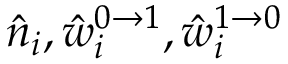Convert formula to latex. <formula><loc_0><loc_0><loc_500><loc_500>\hat { n } _ { i } , \hat { w } _ { i } ^ { 0 \to 1 } , \hat { w } _ { i } ^ { 1 \to 0 }</formula> 